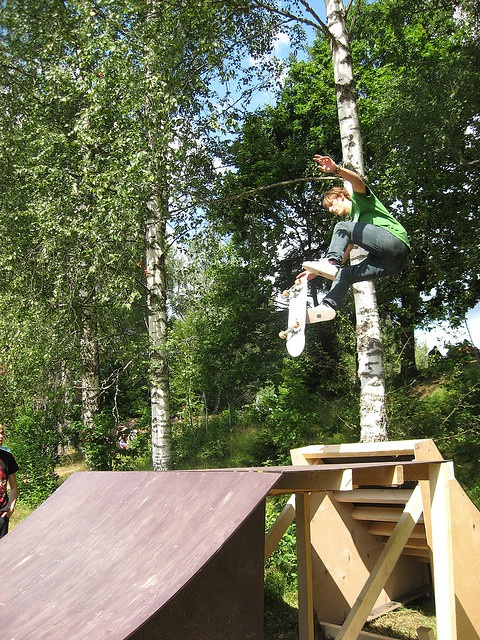Describe the objects in this image and their specific colors. I can see people in gray, black, ivory, and darkgray tones, skateboard in gray, white, darkgray, and beige tones, people in gray, black, olive, and maroon tones, and people in gray, black, white, olive, and maroon tones in this image. 